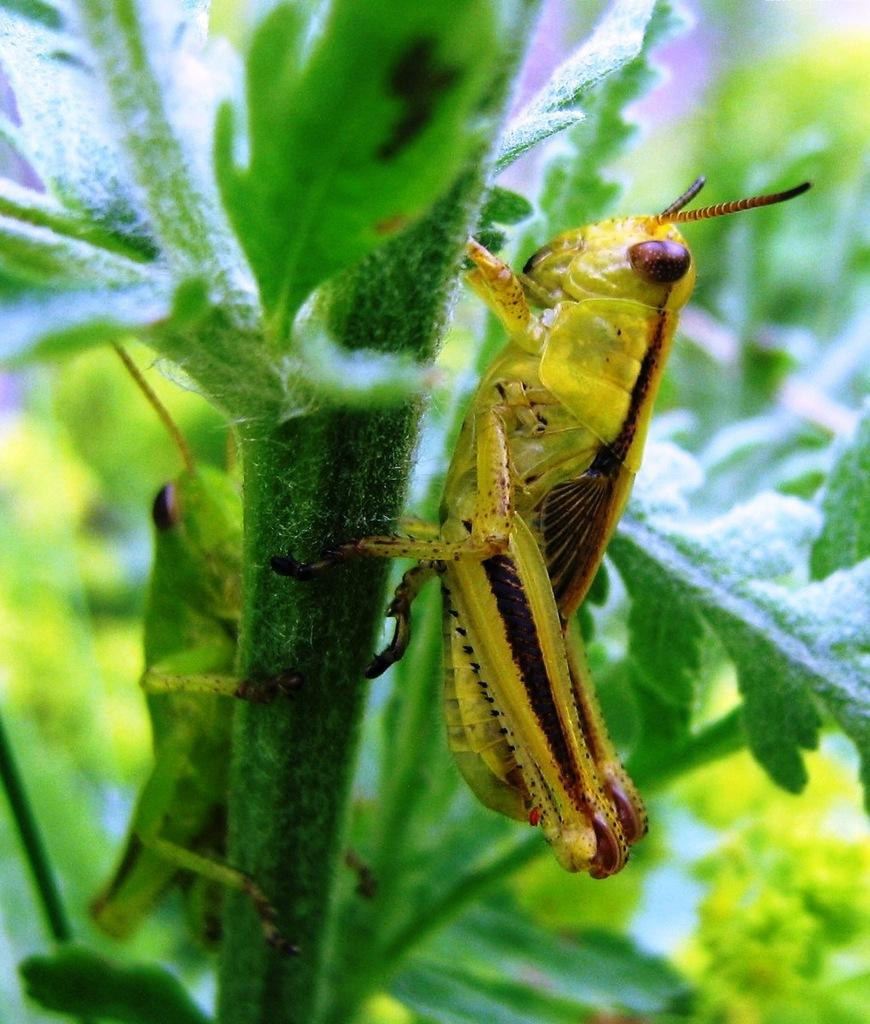How many insects are present in the image? There are two insects in the image. Where are the insects located? The insects are on a plant. What is the insects' opinion on the latest invention in the image? There is no indication of any opinions or inventions in the image, as it only features two insects on a plant. 